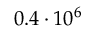Convert formula to latex. <formula><loc_0><loc_0><loc_500><loc_500>0 . 4 \cdot 1 0 ^ { 6 }</formula> 